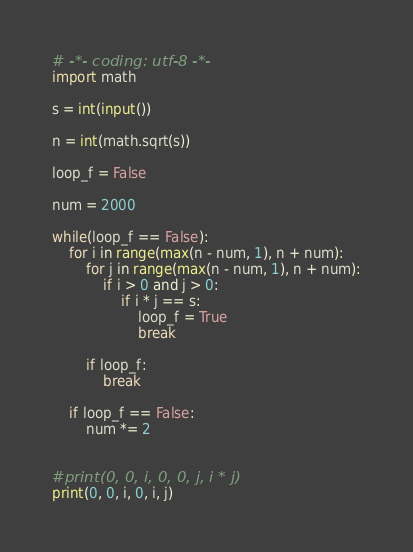Convert code to text. <code><loc_0><loc_0><loc_500><loc_500><_Python_># -*- coding: utf-8 -*-
import math

s = int(input())

n = int(math.sqrt(s))

loop_f = False

num = 2000

while(loop_f == False):
    for i in range(max(n - num, 1), n + num):
        for j in range(max(n - num, 1), n + num):
            if i > 0 and j > 0:
                if i * j == s:
                    loop_f = True
                    break

        if loop_f:
            break

    if loop_f == False:
        num *= 2


#print(0, 0, i, 0, 0, j, i * j)
print(0, 0, i, 0, i, j)</code> 